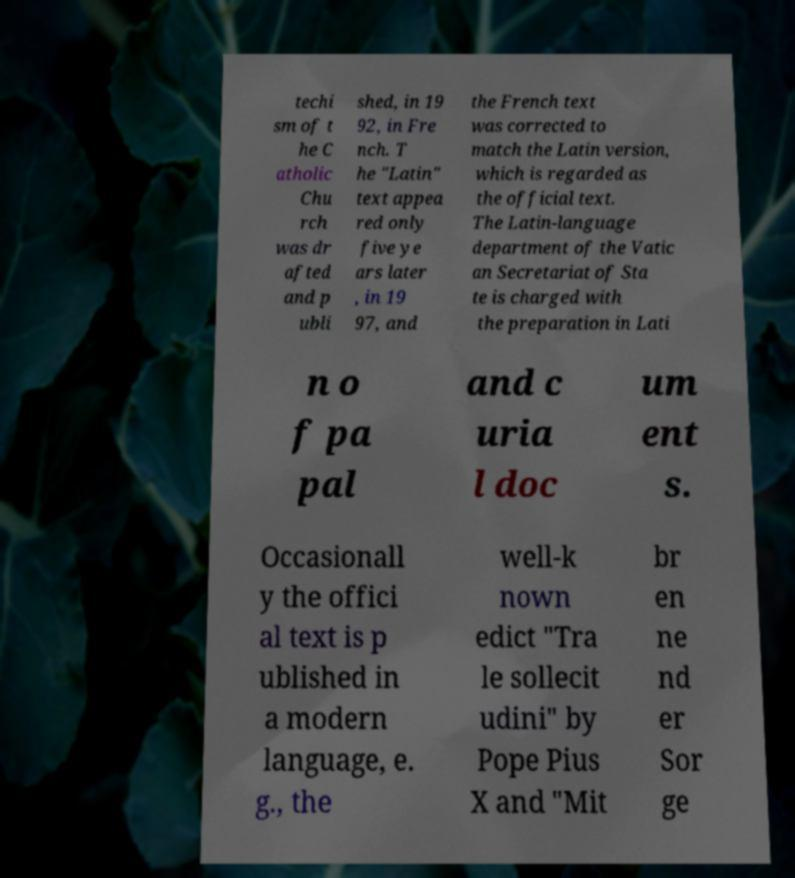Could you assist in decoding the text presented in this image and type it out clearly? techi sm of t he C atholic Chu rch was dr afted and p ubli shed, in 19 92, in Fre nch. T he "Latin" text appea red only five ye ars later , in 19 97, and the French text was corrected to match the Latin version, which is regarded as the official text. The Latin-language department of the Vatic an Secretariat of Sta te is charged with the preparation in Lati n o f pa pal and c uria l doc um ent s. Occasionall y the offici al text is p ublished in a modern language, e. g., the well-k nown edict "Tra le sollecit udini" by Pope Pius X and "Mit br en ne nd er Sor ge 